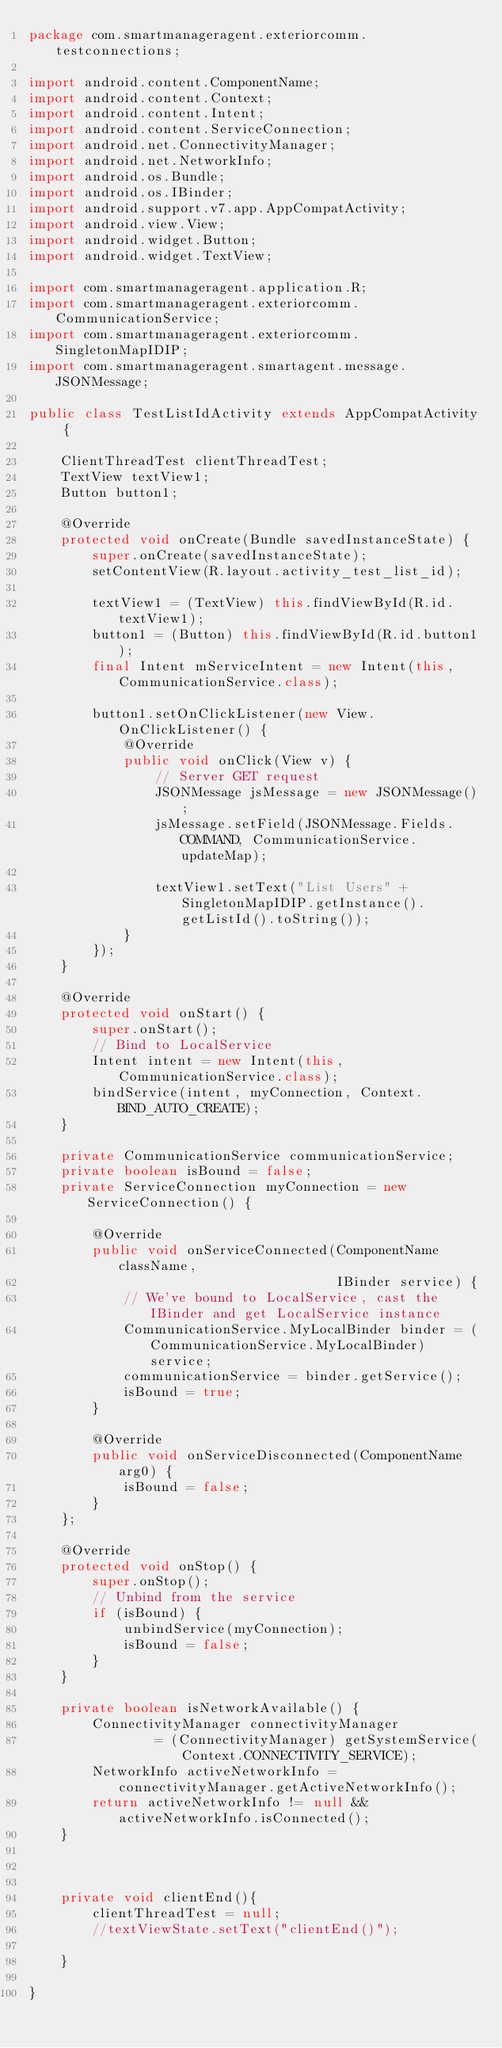Convert code to text. <code><loc_0><loc_0><loc_500><loc_500><_Java_>package com.smartmanageragent.exteriorcomm.testconnections;

import android.content.ComponentName;
import android.content.Context;
import android.content.Intent;
import android.content.ServiceConnection;
import android.net.ConnectivityManager;
import android.net.NetworkInfo;
import android.os.Bundle;
import android.os.IBinder;
import android.support.v7.app.AppCompatActivity;
import android.view.View;
import android.widget.Button;
import android.widget.TextView;

import com.smartmanageragent.application.R;
import com.smartmanageragent.exteriorcomm.CommunicationService;
import com.smartmanageragent.exteriorcomm.SingletonMapIDIP;
import com.smartmanageragent.smartagent.message.JSONMessage;

public class TestListIdActivity extends AppCompatActivity {

    ClientThreadTest clientThreadTest;
    TextView textView1;
    Button button1;

    @Override
    protected void onCreate(Bundle savedInstanceState) {
        super.onCreate(savedInstanceState);
        setContentView(R.layout.activity_test_list_id);

        textView1 = (TextView) this.findViewById(R.id.textView1);
        button1 = (Button) this.findViewById(R.id.button1);
        final Intent mServiceIntent = new Intent(this, CommunicationService.class);

        button1.setOnClickListener(new View.OnClickListener() {
            @Override
            public void onClick(View v) {
                // Server GET request
                JSONMessage jsMessage = new JSONMessage();
                jsMessage.setField(JSONMessage.Fields.COMMAND, CommunicationService.updateMap);

                textView1.setText("List Users" + SingletonMapIDIP.getInstance().getListId().toString());
            }
        });
    }

    @Override
    protected void onStart() {
        super.onStart();
        // Bind to LocalService
        Intent intent = new Intent(this, CommunicationService.class);
        bindService(intent, myConnection, Context.BIND_AUTO_CREATE);
    }

    private CommunicationService communicationService;
    private boolean isBound = false;
    private ServiceConnection myConnection = new ServiceConnection() {

        @Override
        public void onServiceConnected(ComponentName className,
                                       IBinder service) {
            // We've bound to LocalService, cast the IBinder and get LocalService instance
            CommunicationService.MyLocalBinder binder = (CommunicationService.MyLocalBinder) service;
            communicationService = binder.getService();
            isBound = true;
        }

        @Override
        public void onServiceDisconnected(ComponentName arg0) {
            isBound = false;
        }
    };

    @Override
    protected void onStop() {
        super.onStop();
        // Unbind from the service
        if (isBound) {
            unbindService(myConnection);
            isBound = false;
        }
    }

    private boolean isNetworkAvailable() {
        ConnectivityManager connectivityManager
                = (ConnectivityManager) getSystemService(Context.CONNECTIVITY_SERVICE);
        NetworkInfo activeNetworkInfo = connectivityManager.getActiveNetworkInfo();
        return activeNetworkInfo != null && activeNetworkInfo.isConnected();
    }



    private void clientEnd(){
        clientThreadTest = null;
        //textViewState.setText("clientEnd()");

    }

}
</code> 